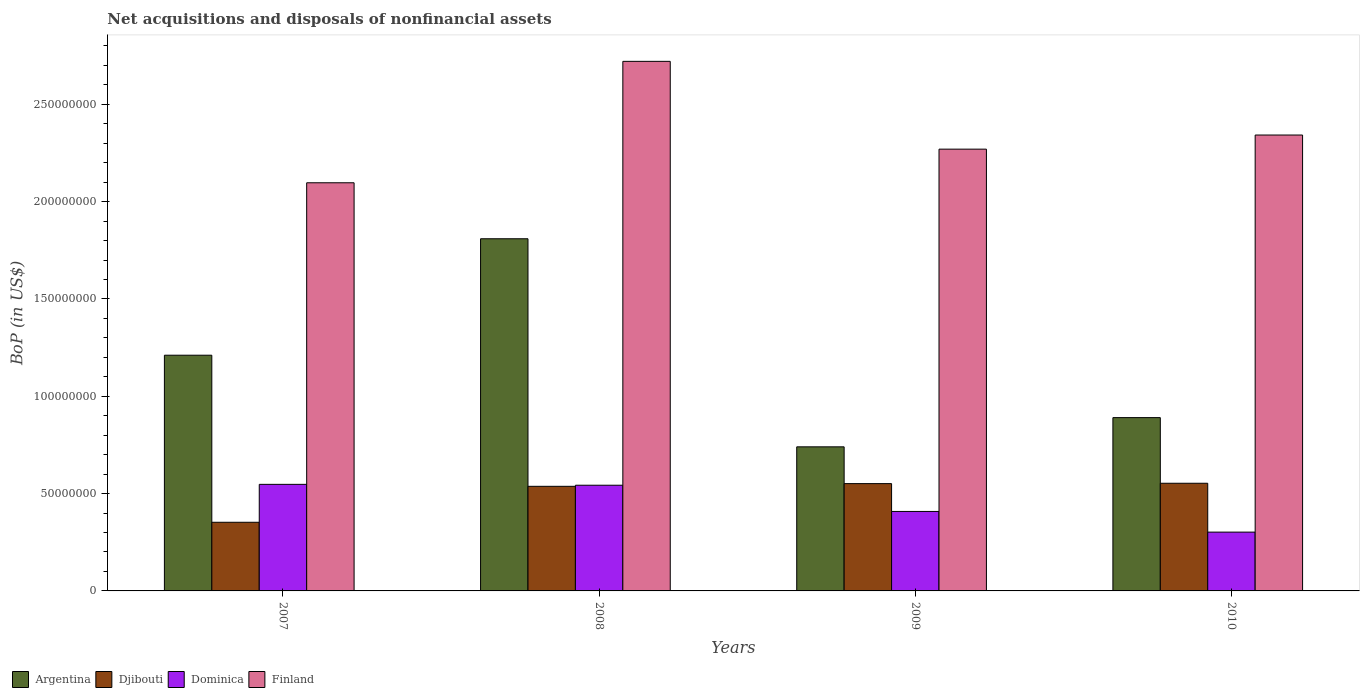How many groups of bars are there?
Your response must be concise. 4. Are the number of bars per tick equal to the number of legend labels?
Provide a succinct answer. Yes. Are the number of bars on each tick of the X-axis equal?
Your answer should be compact. Yes. In how many cases, is the number of bars for a given year not equal to the number of legend labels?
Give a very brief answer. 0. What is the Balance of Payments in Dominica in 2007?
Your response must be concise. 5.47e+07. Across all years, what is the maximum Balance of Payments in Dominica?
Ensure brevity in your answer.  5.47e+07. Across all years, what is the minimum Balance of Payments in Argentina?
Your response must be concise. 7.40e+07. What is the total Balance of Payments in Dominica in the graph?
Your answer should be compact. 1.80e+08. What is the difference between the Balance of Payments in Djibouti in 2008 and that in 2009?
Your response must be concise. -1.39e+06. What is the difference between the Balance of Payments in Argentina in 2007 and the Balance of Payments in Finland in 2008?
Your response must be concise. -1.51e+08. What is the average Balance of Payments in Dominica per year?
Your answer should be compact. 4.50e+07. In the year 2008, what is the difference between the Balance of Payments in Argentina and Balance of Payments in Dominica?
Your response must be concise. 1.27e+08. What is the ratio of the Balance of Payments in Djibouti in 2009 to that in 2010?
Your answer should be very brief. 1. Is the difference between the Balance of Payments in Argentina in 2009 and 2010 greater than the difference between the Balance of Payments in Dominica in 2009 and 2010?
Ensure brevity in your answer.  No. What is the difference between the highest and the second highest Balance of Payments in Dominica?
Your answer should be very brief. 4.48e+05. What is the difference between the highest and the lowest Balance of Payments in Dominica?
Your response must be concise. 2.45e+07. In how many years, is the Balance of Payments in Argentina greater than the average Balance of Payments in Argentina taken over all years?
Offer a very short reply. 2. What does the 3rd bar from the right in 2008 represents?
Make the answer very short. Djibouti. How many years are there in the graph?
Your answer should be compact. 4. Are the values on the major ticks of Y-axis written in scientific E-notation?
Your response must be concise. No. Does the graph contain grids?
Your answer should be very brief. No. How many legend labels are there?
Keep it short and to the point. 4. How are the legend labels stacked?
Your answer should be very brief. Horizontal. What is the title of the graph?
Offer a terse response. Net acquisitions and disposals of nonfinancial assets. What is the label or title of the Y-axis?
Your answer should be compact. BoP (in US$). What is the BoP (in US$) of Argentina in 2007?
Make the answer very short. 1.21e+08. What is the BoP (in US$) of Djibouti in 2007?
Provide a succinct answer. 3.53e+07. What is the BoP (in US$) in Dominica in 2007?
Provide a succinct answer. 5.47e+07. What is the BoP (in US$) of Finland in 2007?
Provide a succinct answer. 2.10e+08. What is the BoP (in US$) in Argentina in 2008?
Provide a succinct answer. 1.81e+08. What is the BoP (in US$) of Djibouti in 2008?
Offer a terse response. 5.37e+07. What is the BoP (in US$) in Dominica in 2008?
Offer a very short reply. 5.43e+07. What is the BoP (in US$) of Finland in 2008?
Offer a terse response. 2.72e+08. What is the BoP (in US$) in Argentina in 2009?
Your answer should be very brief. 7.40e+07. What is the BoP (in US$) of Djibouti in 2009?
Give a very brief answer. 5.51e+07. What is the BoP (in US$) of Dominica in 2009?
Make the answer very short. 4.08e+07. What is the BoP (in US$) of Finland in 2009?
Offer a very short reply. 2.27e+08. What is the BoP (in US$) of Argentina in 2010?
Offer a terse response. 8.90e+07. What is the BoP (in US$) in Djibouti in 2010?
Give a very brief answer. 5.53e+07. What is the BoP (in US$) of Dominica in 2010?
Offer a terse response. 3.02e+07. What is the BoP (in US$) in Finland in 2010?
Your answer should be very brief. 2.34e+08. Across all years, what is the maximum BoP (in US$) of Argentina?
Keep it short and to the point. 1.81e+08. Across all years, what is the maximum BoP (in US$) of Djibouti?
Your response must be concise. 5.53e+07. Across all years, what is the maximum BoP (in US$) in Dominica?
Provide a succinct answer. 5.47e+07. Across all years, what is the maximum BoP (in US$) in Finland?
Your response must be concise. 2.72e+08. Across all years, what is the minimum BoP (in US$) of Argentina?
Offer a very short reply. 7.40e+07. Across all years, what is the minimum BoP (in US$) of Djibouti?
Your answer should be very brief. 3.53e+07. Across all years, what is the minimum BoP (in US$) in Dominica?
Ensure brevity in your answer.  3.02e+07. Across all years, what is the minimum BoP (in US$) of Finland?
Give a very brief answer. 2.10e+08. What is the total BoP (in US$) in Argentina in the graph?
Offer a very short reply. 4.65e+08. What is the total BoP (in US$) of Djibouti in the graph?
Ensure brevity in your answer.  1.99e+08. What is the total BoP (in US$) of Dominica in the graph?
Keep it short and to the point. 1.80e+08. What is the total BoP (in US$) of Finland in the graph?
Offer a terse response. 9.43e+08. What is the difference between the BoP (in US$) in Argentina in 2007 and that in 2008?
Give a very brief answer. -5.98e+07. What is the difference between the BoP (in US$) in Djibouti in 2007 and that in 2008?
Keep it short and to the point. -1.85e+07. What is the difference between the BoP (in US$) in Dominica in 2007 and that in 2008?
Provide a short and direct response. 4.48e+05. What is the difference between the BoP (in US$) in Finland in 2007 and that in 2008?
Your response must be concise. -6.24e+07. What is the difference between the BoP (in US$) of Argentina in 2007 and that in 2009?
Keep it short and to the point. 4.71e+07. What is the difference between the BoP (in US$) in Djibouti in 2007 and that in 2009?
Your response must be concise. -1.99e+07. What is the difference between the BoP (in US$) in Dominica in 2007 and that in 2009?
Ensure brevity in your answer.  1.39e+07. What is the difference between the BoP (in US$) of Finland in 2007 and that in 2009?
Provide a succinct answer. -1.73e+07. What is the difference between the BoP (in US$) of Argentina in 2007 and that in 2010?
Your response must be concise. 3.21e+07. What is the difference between the BoP (in US$) of Djibouti in 2007 and that in 2010?
Ensure brevity in your answer.  -2.00e+07. What is the difference between the BoP (in US$) in Dominica in 2007 and that in 2010?
Keep it short and to the point. 2.45e+07. What is the difference between the BoP (in US$) in Finland in 2007 and that in 2010?
Ensure brevity in your answer.  -2.45e+07. What is the difference between the BoP (in US$) of Argentina in 2008 and that in 2009?
Your response must be concise. 1.07e+08. What is the difference between the BoP (in US$) in Djibouti in 2008 and that in 2009?
Ensure brevity in your answer.  -1.39e+06. What is the difference between the BoP (in US$) of Dominica in 2008 and that in 2009?
Keep it short and to the point. 1.35e+07. What is the difference between the BoP (in US$) of Finland in 2008 and that in 2009?
Your answer should be compact. 4.51e+07. What is the difference between the BoP (in US$) of Argentina in 2008 and that in 2010?
Give a very brief answer. 9.19e+07. What is the difference between the BoP (in US$) in Djibouti in 2008 and that in 2010?
Offer a very short reply. -1.58e+06. What is the difference between the BoP (in US$) in Dominica in 2008 and that in 2010?
Your response must be concise. 2.41e+07. What is the difference between the BoP (in US$) of Finland in 2008 and that in 2010?
Give a very brief answer. 3.79e+07. What is the difference between the BoP (in US$) of Argentina in 2009 and that in 2010?
Your response must be concise. -1.50e+07. What is the difference between the BoP (in US$) of Djibouti in 2009 and that in 2010?
Ensure brevity in your answer.  -1.86e+05. What is the difference between the BoP (in US$) in Dominica in 2009 and that in 2010?
Your answer should be very brief. 1.06e+07. What is the difference between the BoP (in US$) of Finland in 2009 and that in 2010?
Your answer should be compact. -7.25e+06. What is the difference between the BoP (in US$) of Argentina in 2007 and the BoP (in US$) of Djibouti in 2008?
Keep it short and to the point. 6.74e+07. What is the difference between the BoP (in US$) in Argentina in 2007 and the BoP (in US$) in Dominica in 2008?
Your answer should be compact. 6.68e+07. What is the difference between the BoP (in US$) in Argentina in 2007 and the BoP (in US$) in Finland in 2008?
Offer a terse response. -1.51e+08. What is the difference between the BoP (in US$) in Djibouti in 2007 and the BoP (in US$) in Dominica in 2008?
Your answer should be compact. -1.90e+07. What is the difference between the BoP (in US$) of Djibouti in 2007 and the BoP (in US$) of Finland in 2008?
Your answer should be compact. -2.37e+08. What is the difference between the BoP (in US$) of Dominica in 2007 and the BoP (in US$) of Finland in 2008?
Your answer should be compact. -2.17e+08. What is the difference between the BoP (in US$) of Argentina in 2007 and the BoP (in US$) of Djibouti in 2009?
Make the answer very short. 6.60e+07. What is the difference between the BoP (in US$) in Argentina in 2007 and the BoP (in US$) in Dominica in 2009?
Provide a succinct answer. 8.03e+07. What is the difference between the BoP (in US$) in Argentina in 2007 and the BoP (in US$) in Finland in 2009?
Offer a terse response. -1.06e+08. What is the difference between the BoP (in US$) in Djibouti in 2007 and the BoP (in US$) in Dominica in 2009?
Your answer should be compact. -5.57e+06. What is the difference between the BoP (in US$) in Djibouti in 2007 and the BoP (in US$) in Finland in 2009?
Give a very brief answer. -1.92e+08. What is the difference between the BoP (in US$) in Dominica in 2007 and the BoP (in US$) in Finland in 2009?
Your answer should be very brief. -1.72e+08. What is the difference between the BoP (in US$) of Argentina in 2007 and the BoP (in US$) of Djibouti in 2010?
Provide a succinct answer. 6.58e+07. What is the difference between the BoP (in US$) in Argentina in 2007 and the BoP (in US$) in Dominica in 2010?
Your response must be concise. 9.09e+07. What is the difference between the BoP (in US$) in Argentina in 2007 and the BoP (in US$) in Finland in 2010?
Provide a short and direct response. -1.13e+08. What is the difference between the BoP (in US$) in Djibouti in 2007 and the BoP (in US$) in Dominica in 2010?
Ensure brevity in your answer.  5.05e+06. What is the difference between the BoP (in US$) in Djibouti in 2007 and the BoP (in US$) in Finland in 2010?
Offer a very short reply. -1.99e+08. What is the difference between the BoP (in US$) of Dominica in 2007 and the BoP (in US$) of Finland in 2010?
Provide a succinct answer. -1.79e+08. What is the difference between the BoP (in US$) of Argentina in 2008 and the BoP (in US$) of Djibouti in 2009?
Keep it short and to the point. 1.26e+08. What is the difference between the BoP (in US$) of Argentina in 2008 and the BoP (in US$) of Dominica in 2009?
Give a very brief answer. 1.40e+08. What is the difference between the BoP (in US$) of Argentina in 2008 and the BoP (in US$) of Finland in 2009?
Provide a short and direct response. -4.60e+07. What is the difference between the BoP (in US$) of Djibouti in 2008 and the BoP (in US$) of Dominica in 2009?
Offer a terse response. 1.29e+07. What is the difference between the BoP (in US$) of Djibouti in 2008 and the BoP (in US$) of Finland in 2009?
Ensure brevity in your answer.  -1.73e+08. What is the difference between the BoP (in US$) of Dominica in 2008 and the BoP (in US$) of Finland in 2009?
Offer a very short reply. -1.73e+08. What is the difference between the BoP (in US$) of Argentina in 2008 and the BoP (in US$) of Djibouti in 2010?
Provide a succinct answer. 1.26e+08. What is the difference between the BoP (in US$) in Argentina in 2008 and the BoP (in US$) in Dominica in 2010?
Your response must be concise. 1.51e+08. What is the difference between the BoP (in US$) of Argentina in 2008 and the BoP (in US$) of Finland in 2010?
Make the answer very short. -5.33e+07. What is the difference between the BoP (in US$) in Djibouti in 2008 and the BoP (in US$) in Dominica in 2010?
Offer a very short reply. 2.35e+07. What is the difference between the BoP (in US$) of Djibouti in 2008 and the BoP (in US$) of Finland in 2010?
Offer a very short reply. -1.80e+08. What is the difference between the BoP (in US$) in Dominica in 2008 and the BoP (in US$) in Finland in 2010?
Offer a terse response. -1.80e+08. What is the difference between the BoP (in US$) of Argentina in 2009 and the BoP (in US$) of Djibouti in 2010?
Keep it short and to the point. 1.87e+07. What is the difference between the BoP (in US$) in Argentina in 2009 and the BoP (in US$) in Dominica in 2010?
Offer a very short reply. 4.38e+07. What is the difference between the BoP (in US$) in Argentina in 2009 and the BoP (in US$) in Finland in 2010?
Your response must be concise. -1.60e+08. What is the difference between the BoP (in US$) of Djibouti in 2009 and the BoP (in US$) of Dominica in 2010?
Give a very brief answer. 2.49e+07. What is the difference between the BoP (in US$) of Djibouti in 2009 and the BoP (in US$) of Finland in 2010?
Your answer should be very brief. -1.79e+08. What is the difference between the BoP (in US$) in Dominica in 2009 and the BoP (in US$) in Finland in 2010?
Your answer should be compact. -1.93e+08. What is the average BoP (in US$) in Argentina per year?
Offer a very short reply. 1.16e+08. What is the average BoP (in US$) of Djibouti per year?
Ensure brevity in your answer.  4.99e+07. What is the average BoP (in US$) in Dominica per year?
Give a very brief answer. 4.50e+07. What is the average BoP (in US$) of Finland per year?
Your answer should be compact. 2.36e+08. In the year 2007, what is the difference between the BoP (in US$) of Argentina and BoP (in US$) of Djibouti?
Offer a very short reply. 8.58e+07. In the year 2007, what is the difference between the BoP (in US$) of Argentina and BoP (in US$) of Dominica?
Your answer should be very brief. 6.64e+07. In the year 2007, what is the difference between the BoP (in US$) in Argentina and BoP (in US$) in Finland?
Give a very brief answer. -8.86e+07. In the year 2007, what is the difference between the BoP (in US$) in Djibouti and BoP (in US$) in Dominica?
Give a very brief answer. -1.95e+07. In the year 2007, what is the difference between the BoP (in US$) in Djibouti and BoP (in US$) in Finland?
Your response must be concise. -1.74e+08. In the year 2007, what is the difference between the BoP (in US$) in Dominica and BoP (in US$) in Finland?
Offer a very short reply. -1.55e+08. In the year 2008, what is the difference between the BoP (in US$) of Argentina and BoP (in US$) of Djibouti?
Your answer should be compact. 1.27e+08. In the year 2008, what is the difference between the BoP (in US$) of Argentina and BoP (in US$) of Dominica?
Provide a succinct answer. 1.27e+08. In the year 2008, what is the difference between the BoP (in US$) of Argentina and BoP (in US$) of Finland?
Your answer should be very brief. -9.11e+07. In the year 2008, what is the difference between the BoP (in US$) in Djibouti and BoP (in US$) in Dominica?
Ensure brevity in your answer.  -5.60e+05. In the year 2008, what is the difference between the BoP (in US$) in Djibouti and BoP (in US$) in Finland?
Give a very brief answer. -2.18e+08. In the year 2008, what is the difference between the BoP (in US$) of Dominica and BoP (in US$) of Finland?
Keep it short and to the point. -2.18e+08. In the year 2009, what is the difference between the BoP (in US$) in Argentina and BoP (in US$) in Djibouti?
Your answer should be very brief. 1.89e+07. In the year 2009, what is the difference between the BoP (in US$) of Argentina and BoP (in US$) of Dominica?
Ensure brevity in your answer.  3.32e+07. In the year 2009, what is the difference between the BoP (in US$) in Argentina and BoP (in US$) in Finland?
Make the answer very short. -1.53e+08. In the year 2009, what is the difference between the BoP (in US$) in Djibouti and BoP (in US$) in Dominica?
Give a very brief answer. 1.43e+07. In the year 2009, what is the difference between the BoP (in US$) of Djibouti and BoP (in US$) of Finland?
Offer a very short reply. -1.72e+08. In the year 2009, what is the difference between the BoP (in US$) of Dominica and BoP (in US$) of Finland?
Keep it short and to the point. -1.86e+08. In the year 2010, what is the difference between the BoP (in US$) of Argentina and BoP (in US$) of Djibouti?
Provide a succinct answer. 3.37e+07. In the year 2010, what is the difference between the BoP (in US$) of Argentina and BoP (in US$) of Dominica?
Offer a very short reply. 5.88e+07. In the year 2010, what is the difference between the BoP (in US$) of Argentina and BoP (in US$) of Finland?
Offer a very short reply. -1.45e+08. In the year 2010, what is the difference between the BoP (in US$) of Djibouti and BoP (in US$) of Dominica?
Offer a terse response. 2.51e+07. In the year 2010, what is the difference between the BoP (in US$) of Djibouti and BoP (in US$) of Finland?
Offer a very short reply. -1.79e+08. In the year 2010, what is the difference between the BoP (in US$) in Dominica and BoP (in US$) in Finland?
Make the answer very short. -2.04e+08. What is the ratio of the BoP (in US$) of Argentina in 2007 to that in 2008?
Your answer should be compact. 0.67. What is the ratio of the BoP (in US$) of Djibouti in 2007 to that in 2008?
Keep it short and to the point. 0.66. What is the ratio of the BoP (in US$) of Dominica in 2007 to that in 2008?
Keep it short and to the point. 1.01. What is the ratio of the BoP (in US$) in Finland in 2007 to that in 2008?
Your answer should be compact. 0.77. What is the ratio of the BoP (in US$) of Argentina in 2007 to that in 2009?
Offer a very short reply. 1.64. What is the ratio of the BoP (in US$) in Djibouti in 2007 to that in 2009?
Provide a succinct answer. 0.64. What is the ratio of the BoP (in US$) in Dominica in 2007 to that in 2009?
Give a very brief answer. 1.34. What is the ratio of the BoP (in US$) in Finland in 2007 to that in 2009?
Offer a very short reply. 0.92. What is the ratio of the BoP (in US$) in Argentina in 2007 to that in 2010?
Your answer should be very brief. 1.36. What is the ratio of the BoP (in US$) in Djibouti in 2007 to that in 2010?
Keep it short and to the point. 0.64. What is the ratio of the BoP (in US$) in Dominica in 2007 to that in 2010?
Provide a succinct answer. 1.81. What is the ratio of the BoP (in US$) of Finland in 2007 to that in 2010?
Your response must be concise. 0.9. What is the ratio of the BoP (in US$) of Argentina in 2008 to that in 2009?
Your answer should be compact. 2.44. What is the ratio of the BoP (in US$) in Djibouti in 2008 to that in 2009?
Make the answer very short. 0.97. What is the ratio of the BoP (in US$) of Dominica in 2008 to that in 2009?
Your answer should be very brief. 1.33. What is the ratio of the BoP (in US$) of Finland in 2008 to that in 2009?
Your answer should be compact. 1.2. What is the ratio of the BoP (in US$) of Argentina in 2008 to that in 2010?
Your response must be concise. 2.03. What is the ratio of the BoP (in US$) of Djibouti in 2008 to that in 2010?
Offer a terse response. 0.97. What is the ratio of the BoP (in US$) of Dominica in 2008 to that in 2010?
Your answer should be very brief. 1.8. What is the ratio of the BoP (in US$) of Finland in 2008 to that in 2010?
Provide a short and direct response. 1.16. What is the ratio of the BoP (in US$) in Argentina in 2009 to that in 2010?
Ensure brevity in your answer.  0.83. What is the ratio of the BoP (in US$) in Dominica in 2009 to that in 2010?
Keep it short and to the point. 1.35. What is the difference between the highest and the second highest BoP (in US$) of Argentina?
Provide a succinct answer. 5.98e+07. What is the difference between the highest and the second highest BoP (in US$) in Djibouti?
Offer a terse response. 1.86e+05. What is the difference between the highest and the second highest BoP (in US$) of Dominica?
Keep it short and to the point. 4.48e+05. What is the difference between the highest and the second highest BoP (in US$) of Finland?
Provide a succinct answer. 3.79e+07. What is the difference between the highest and the lowest BoP (in US$) in Argentina?
Provide a short and direct response. 1.07e+08. What is the difference between the highest and the lowest BoP (in US$) of Djibouti?
Offer a very short reply. 2.00e+07. What is the difference between the highest and the lowest BoP (in US$) of Dominica?
Make the answer very short. 2.45e+07. What is the difference between the highest and the lowest BoP (in US$) of Finland?
Offer a terse response. 6.24e+07. 